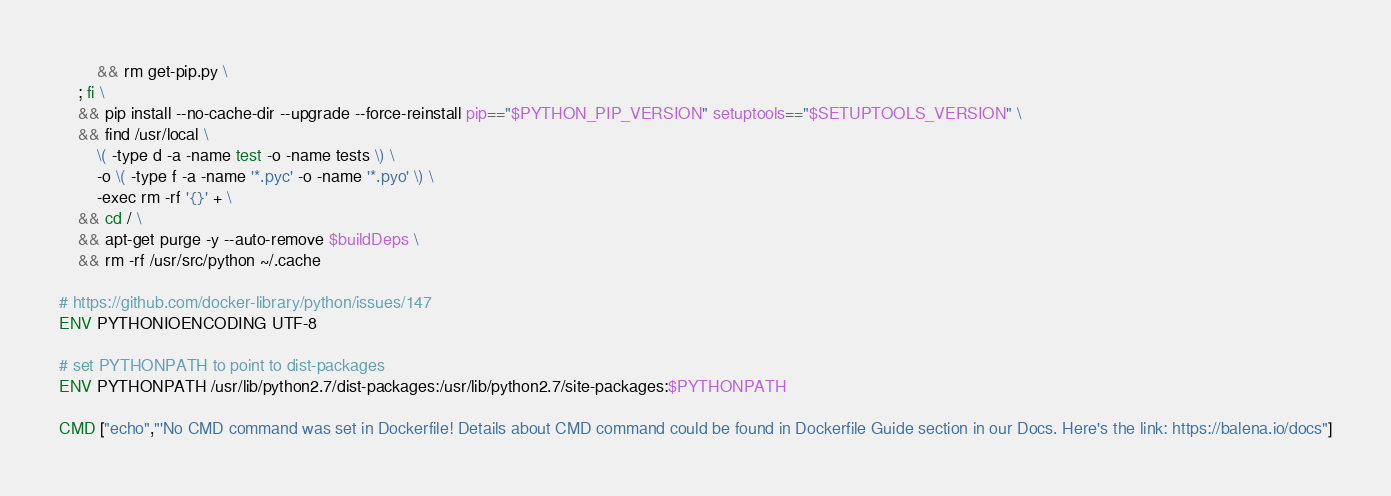<code> <loc_0><loc_0><loc_500><loc_500><_Dockerfile_>		&& rm get-pip.py \
	; fi \
	&& pip install --no-cache-dir --upgrade --force-reinstall pip=="$PYTHON_PIP_VERSION" setuptools=="$SETUPTOOLS_VERSION" \
	&& find /usr/local \
		\( -type d -a -name test -o -name tests \) \
		-o \( -type f -a -name '*.pyc' -o -name '*.pyo' \) \
		-exec rm -rf '{}' + \
	&& cd / \
	&& apt-get purge -y --auto-remove $buildDeps \
	&& rm -rf /usr/src/python ~/.cache

# https://github.com/docker-library/python/issues/147
ENV PYTHONIOENCODING UTF-8

# set PYTHONPATH to point to dist-packages
ENV PYTHONPATH /usr/lib/python2.7/dist-packages:/usr/lib/python2.7/site-packages:$PYTHONPATH

CMD ["echo","'No CMD command was set in Dockerfile! Details about CMD command could be found in Dockerfile Guide section in our Docs. Here's the link: https://balena.io/docs"]</code> 